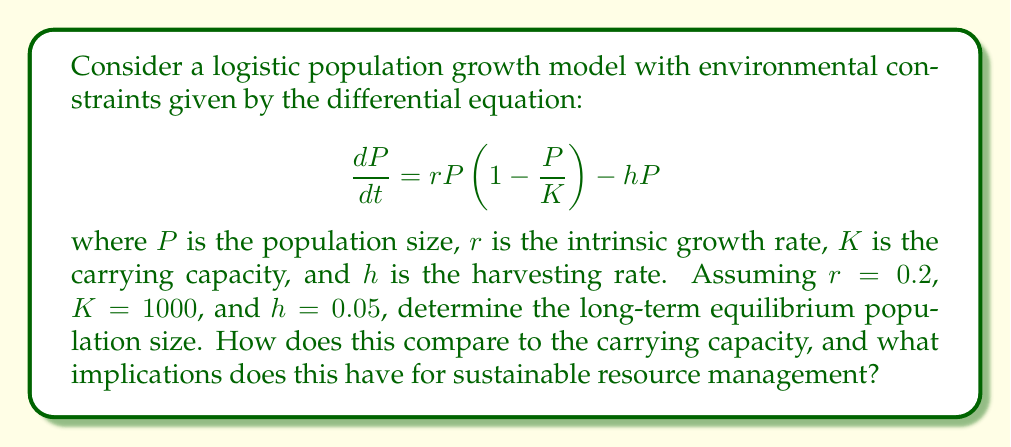Could you help me with this problem? To analyze the long-term behavior of this population growth model, we need to follow these steps:

1. Find the equilibrium points by setting $\frac{dP}{dt} = 0$:

   $$0 = rP\left(1 - \frac{P}{K}\right) - hP$$

2. Factor out $P$:

   $$0 = P\left[r\left(1 - \frac{P}{K}\right) - h\right]$$

3. Solve for $P$:
   
   $P = 0$ or $r\left(1 - \frac{P}{K}\right) - h = 0$

4. For the non-zero equilibrium, solve:

   $$r - \frac{rP}{K} - h = 0$$
   $$r - h = \frac{rP}{K}$$
   $$P = K\left(1 - \frac{h}{r}\right)$$

5. Substitute the given values:

   $$P = 1000\left(1 - \frac{0.05}{0.2}\right) = 1000(0.75) = 750$$

6. Compare to carrying capacity:
   The equilibrium population (750) is 75% of the carrying capacity (1000).

7. Implications for sustainable resource management:
   This model shows that harvesting reduces the equilibrium population below the carrying capacity. The harvesting rate of 0.05 allows for a sustainable population at 75% of the carrying capacity. This balance between population growth and harvesting is crucial for long-term sustainability.
Answer: 750 individuals; 75% of carrying capacity 